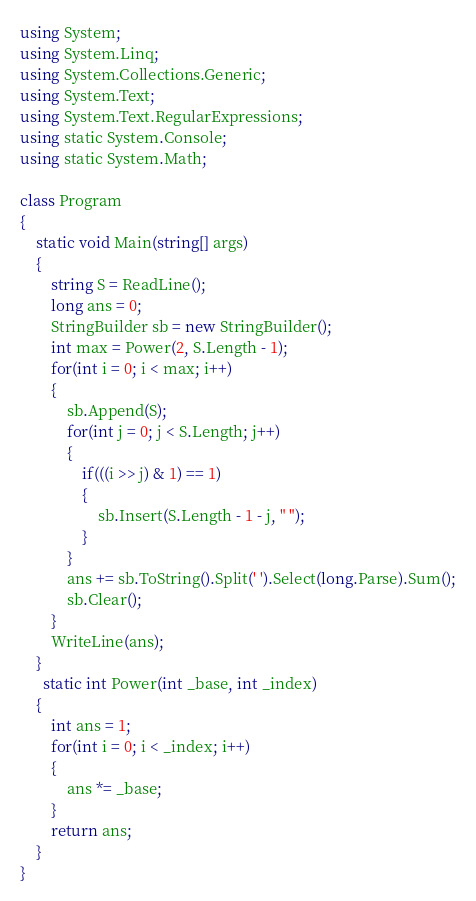<code> <loc_0><loc_0><loc_500><loc_500><_C#_>using System;
using System.Linq;
using System.Collections.Generic;
using System.Text;
using System.Text.RegularExpressions;
using static System.Console;
using static System.Math;

class Program
{
    static void Main(string[] args)
    {
        string S = ReadLine();
        long ans = 0;
        StringBuilder sb = new StringBuilder();
        int max = Power(2, S.Length - 1);
        for(int i = 0; i < max; i++)
        {
            sb.Append(S);
            for(int j = 0; j < S.Length; j++)
            {
                if(((i >> j) & 1) == 1)
                {
                    sb.Insert(S.Length - 1 - j, " ");
                }
            }
            ans += sb.ToString().Split(' ').Select(long.Parse).Sum();
            sb.Clear();
        }
        WriteLine(ans);
    }
      static int Power(int _base, int _index)
    {
        int ans = 1;
        for(int i = 0; i < _index; i++)
        {
            ans *= _base;
        }
        return ans;
    }
}</code> 